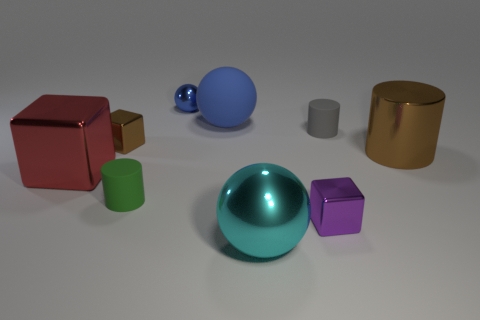Add 1 brown rubber balls. How many objects exist? 10 Subtract all blocks. How many objects are left? 6 Subtract 0 blue cylinders. How many objects are left? 9 Subtract all cyan cubes. Subtract all large balls. How many objects are left? 7 Add 2 large blue objects. How many large blue objects are left? 3 Add 1 red metallic cubes. How many red metallic cubes exist? 2 